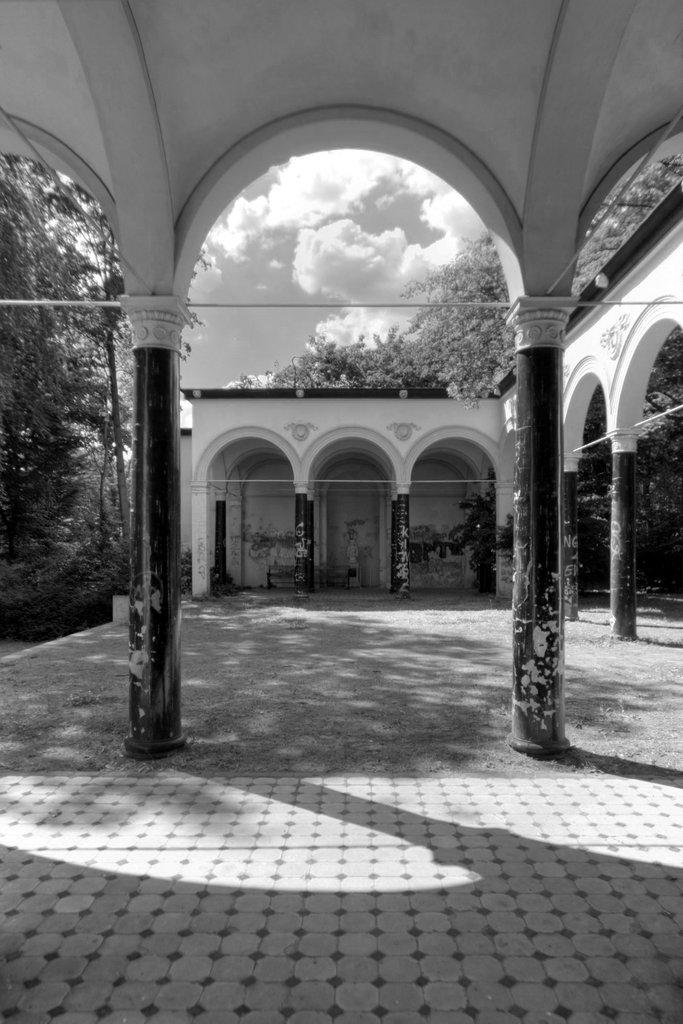What is the color scheme of the image? A: The image is black and white. What type of surface can be seen in the image? There is ground visible in the image. What architectural features are present in the image? There are pillars and a roof in the image. What type of vegetation is present in the image? Trees are present in the image. What is visible in the background of the image? The sky is visible in the background of the image. What can be observed in the sky? Clouds are present in the sky. What type of spacecraft can be seen in the image? There is no spacecraft present in the image; it is a black and white image featuring ground, pillars, a roof, trees, and a sky with clouds. How does the wind affect the pillars in the image? The image does not show any wind or its effects on the pillars; it is a still image. 